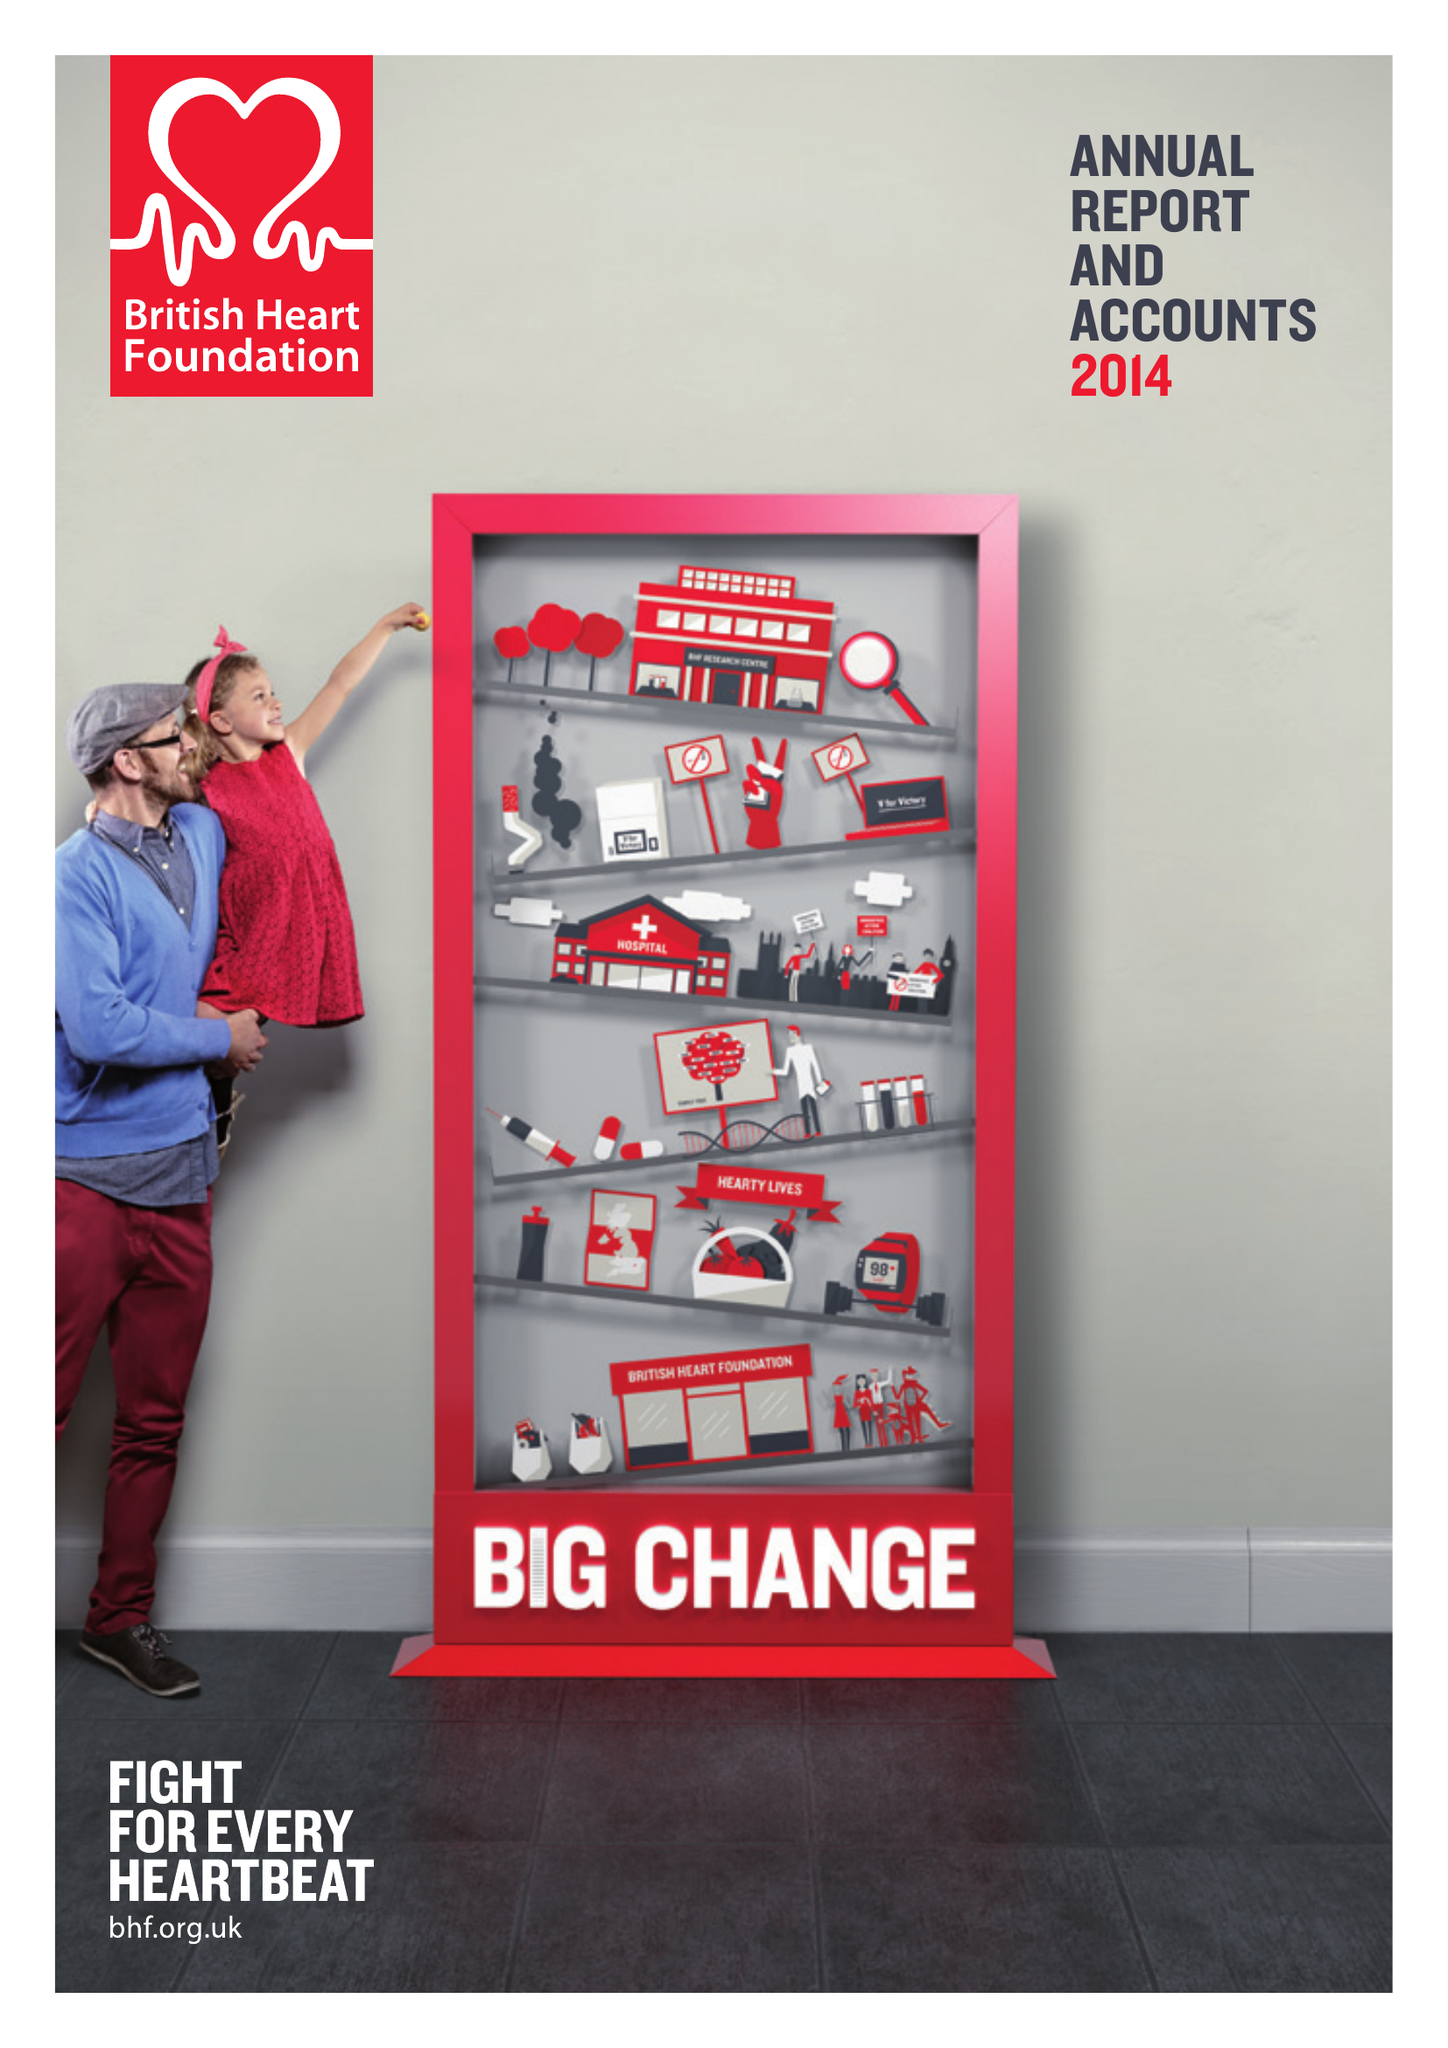What is the value for the charity_number?
Answer the question using a single word or phrase. 225971 